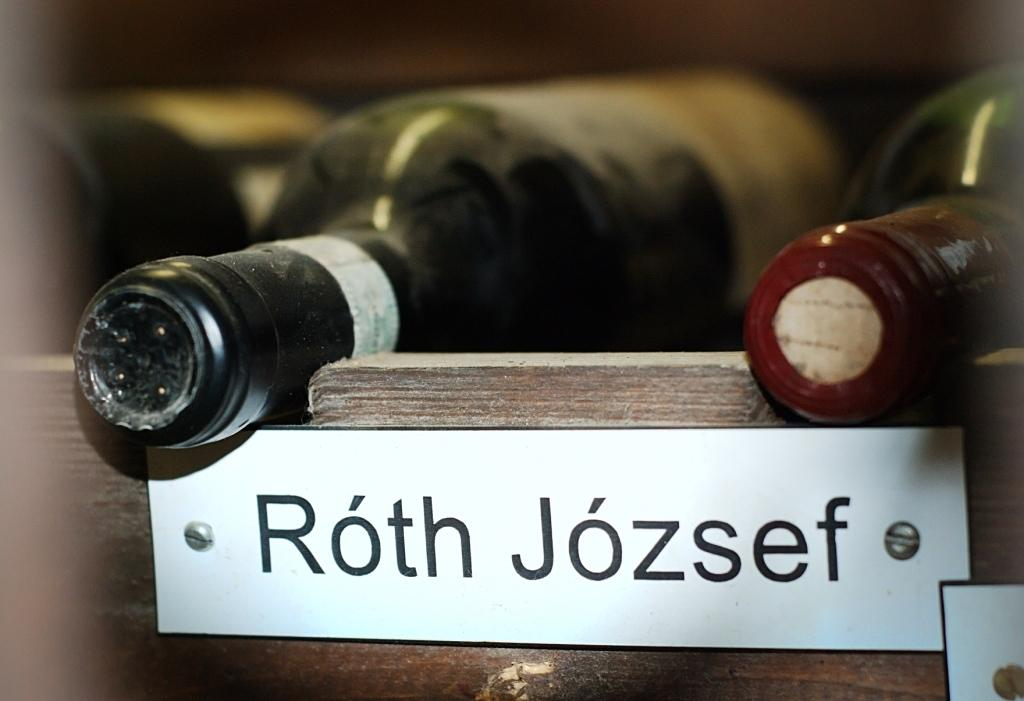Provide a one-sentence caption for the provided image. Two bottles of wine lay in a rack over a label that reads "Roth Jozsef". 